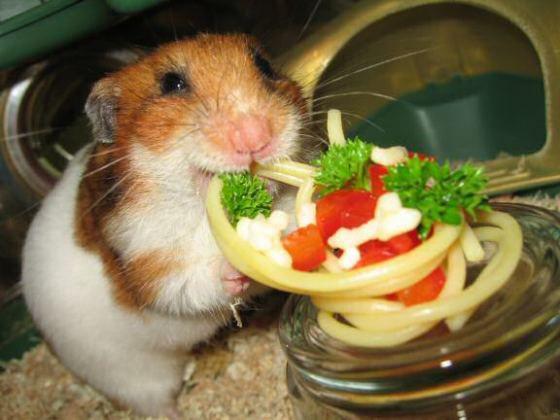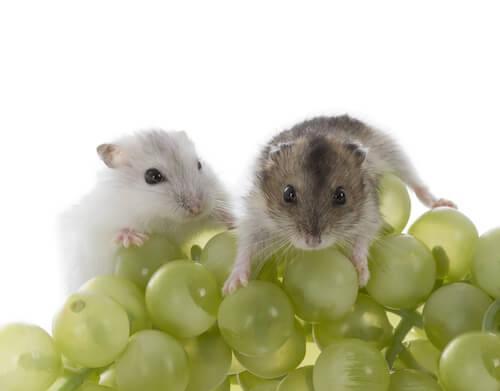The first image is the image on the left, the second image is the image on the right. Analyze the images presented: Is the assertion "Some of these hamsters are eating """"people food""""." valid? Answer yes or no. Yes. 